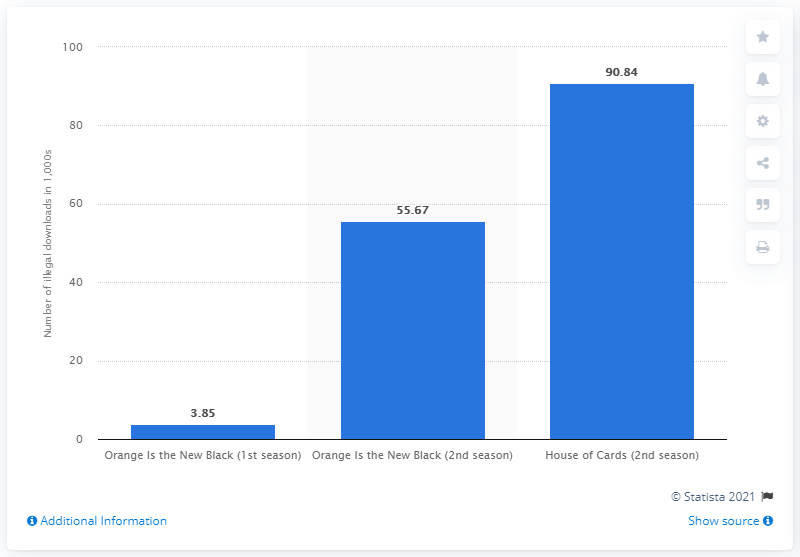Highlight a few significant elements in this photo. Ninety-zero-eight-dot-four illegal downloads were detected two days after the premiere of House of Cards. 